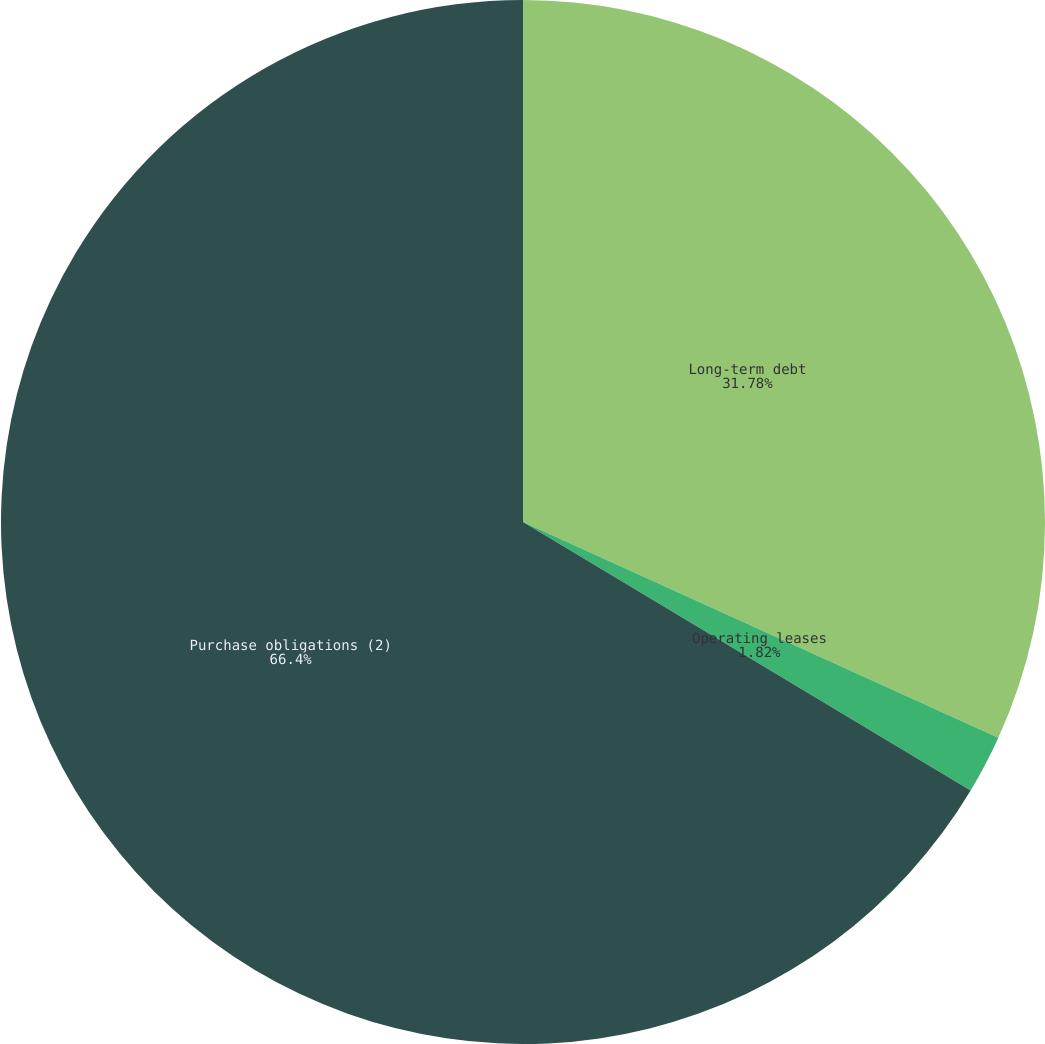<chart> <loc_0><loc_0><loc_500><loc_500><pie_chart><fcel>Long-term debt<fcel>Operating leases<fcel>Purchase obligations (2)<nl><fcel>31.78%<fcel>1.82%<fcel>66.4%<nl></chart> 